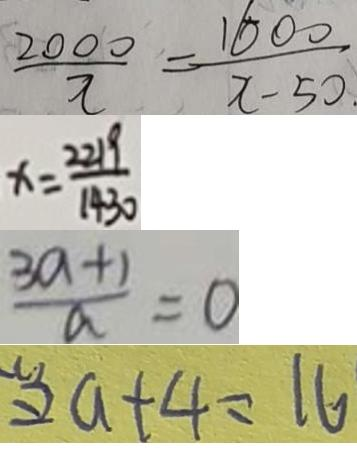Convert formula to latex. <formula><loc_0><loc_0><loc_500><loc_500>\frac { 2 0 0 0 } { x } = \frac { 1 6 0 0 } { x - 5 0 } 
 x = \frac { 2 2 1 9 } { 1 4 3 0 } 
 \frac { 3 a + 1 } { a } = 0 
 2 a + 4 = 1 6</formula> 